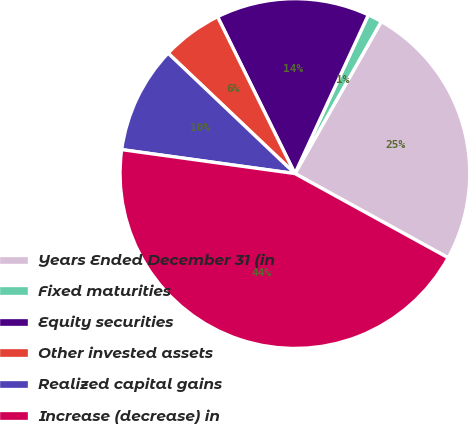Convert chart. <chart><loc_0><loc_0><loc_500><loc_500><pie_chart><fcel>Years Ended December 31 (in<fcel>Fixed maturities<fcel>Equity securities<fcel>Other invested assets<fcel>Realized capital gains<fcel>Increase (decrease) in<nl><fcel>24.77%<fcel>1.33%<fcel>14.19%<fcel>5.62%<fcel>9.9%<fcel>44.19%<nl></chart> 